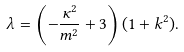Convert formula to latex. <formula><loc_0><loc_0><loc_500><loc_500>\lambda = \left ( - \frac { \kappa ^ { 2 } } { m ^ { 2 } } + 3 \right ) ( 1 + k ^ { 2 } ) .</formula> 